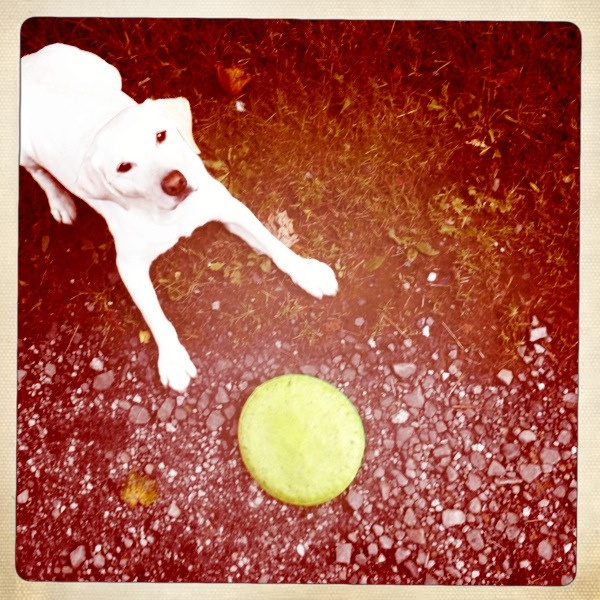Describe the objects in this image and their specific colors. I can see dog in beige, white, lightpink, and brown tones and frisbee in beige, khaki, lightyellow, and tan tones in this image. 